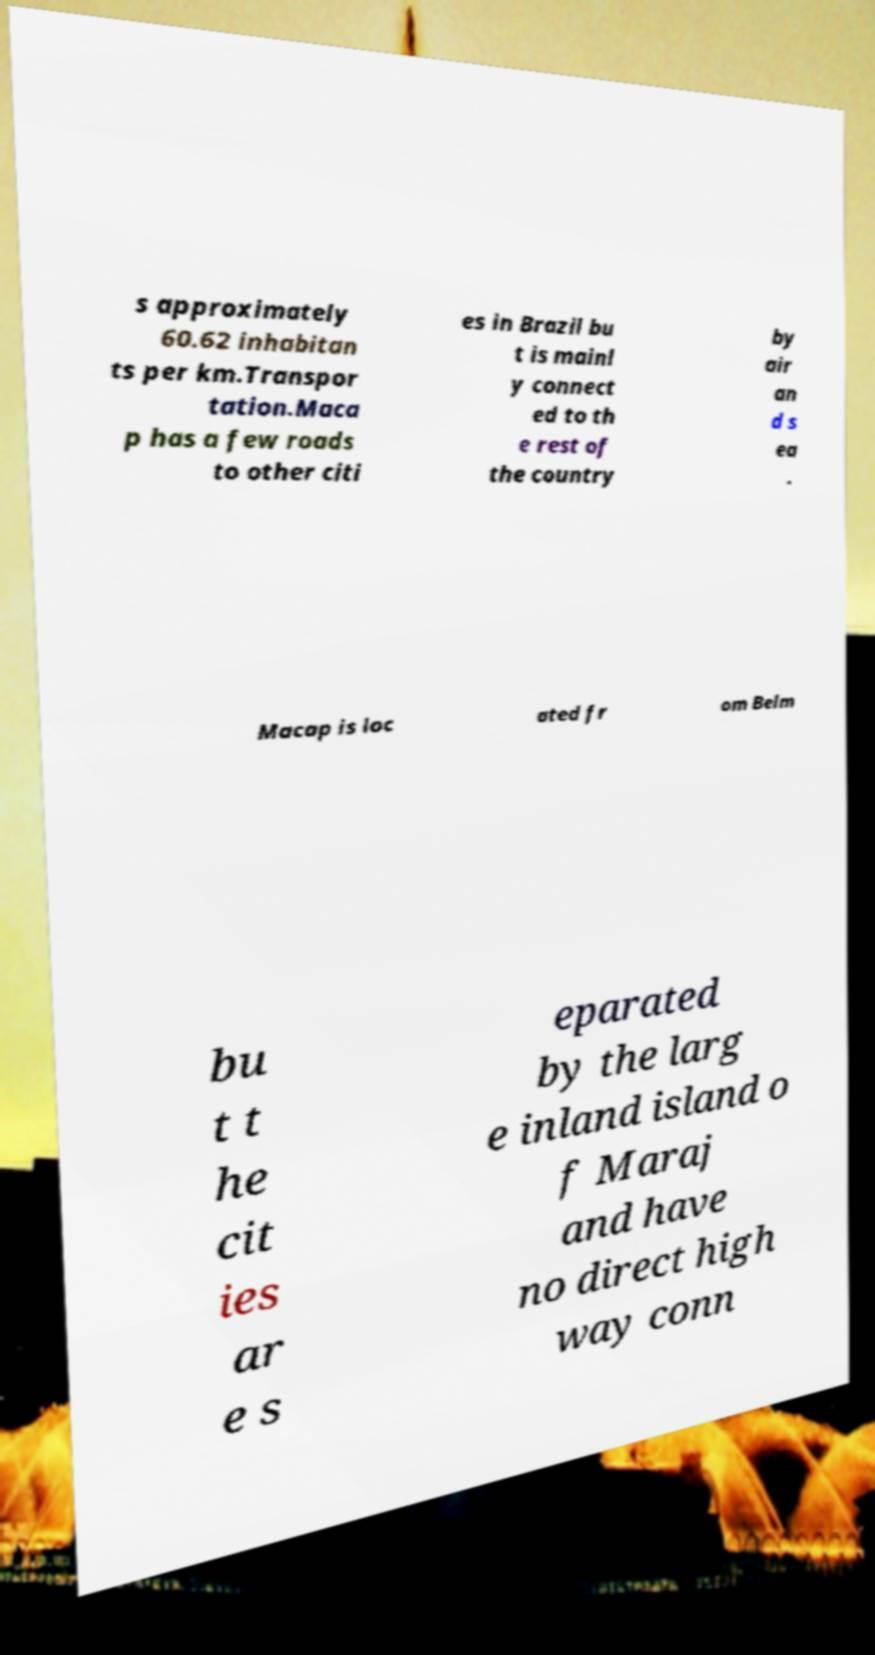Could you extract and type out the text from this image? s approximately 60.62 inhabitan ts per km.Transpor tation.Maca p has a few roads to other citi es in Brazil bu t is mainl y connect ed to th e rest of the country by air an d s ea . Macap is loc ated fr om Belm bu t t he cit ies ar e s eparated by the larg e inland island o f Maraj and have no direct high way conn 